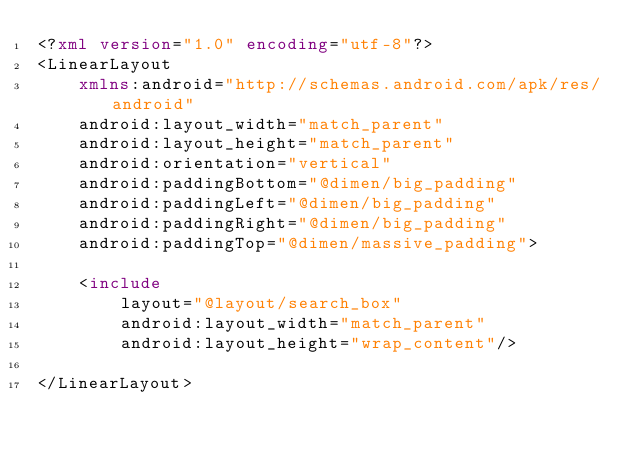Convert code to text. <code><loc_0><loc_0><loc_500><loc_500><_XML_><?xml version="1.0" encoding="utf-8"?>
<LinearLayout
    xmlns:android="http://schemas.android.com/apk/res/android"
    android:layout_width="match_parent"
    android:layout_height="match_parent"
    android:orientation="vertical"
    android:paddingBottom="@dimen/big_padding"
    android:paddingLeft="@dimen/big_padding"
    android:paddingRight="@dimen/big_padding"
    android:paddingTop="@dimen/massive_padding">

    <include
        layout="@layout/search_box"
        android:layout_width="match_parent"
        android:layout_height="wrap_content"/>

</LinearLayout></code> 